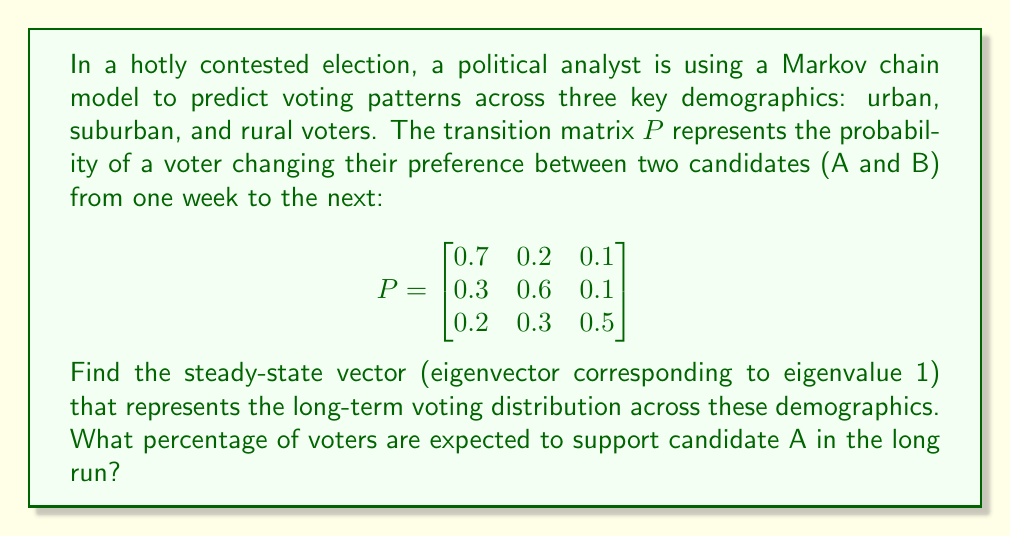What is the answer to this math problem? To find the steady-state vector, we need to solve the equation:

$$\pi P = \pi$$

where $\pi$ is the steady-state vector we're looking for.

Let $\pi = [x, y, z]$. Then we have:

$$[x, y, z] \begin{bmatrix}
0.7 & 0.2 & 0.1 \\
0.3 & 0.6 & 0.1 \\
0.2 & 0.3 & 0.5
\end{bmatrix} = [x, y, z]$$

This gives us the system of equations:

1) $0.7x + 0.3y + 0.2z = x$
2) $0.2x + 0.6y + 0.3z = y$
3) $0.1x + 0.1y + 0.5z = z$

We also know that $x + y + z = 1$ since these represent probabilities.

Simplifying the equations:

1) $-0.3x + 0.3y + 0.2z = 0$
2) $0.2x - 0.4y + 0.3z = 0$
3) $0.1x + 0.1y - 0.5z = 0$
4) $x + y + z = 1$

Solving this system (you can use Gaussian elimination or a calculator), we get:

$$\pi = [0.4545, 0.3636, 0.1818]$$

This means that in the long run:
- 45.45% of voters will be in the urban demographic
- 36.36% will be in the suburban demographic
- 18.18% will be in the rural demographic

To find the percentage supporting candidate A, we need additional information about the current support in each demographic. Since this isn't provided, we can't determine the exact percentage supporting candidate A in the long run.
Answer: The steady-state vector is $\pi = [0.4545, 0.3636, 0.1818]$. Without additional information about current support for candidate A in each demographic, we cannot determine the exact percentage of voters expected to support candidate A in the long run. 